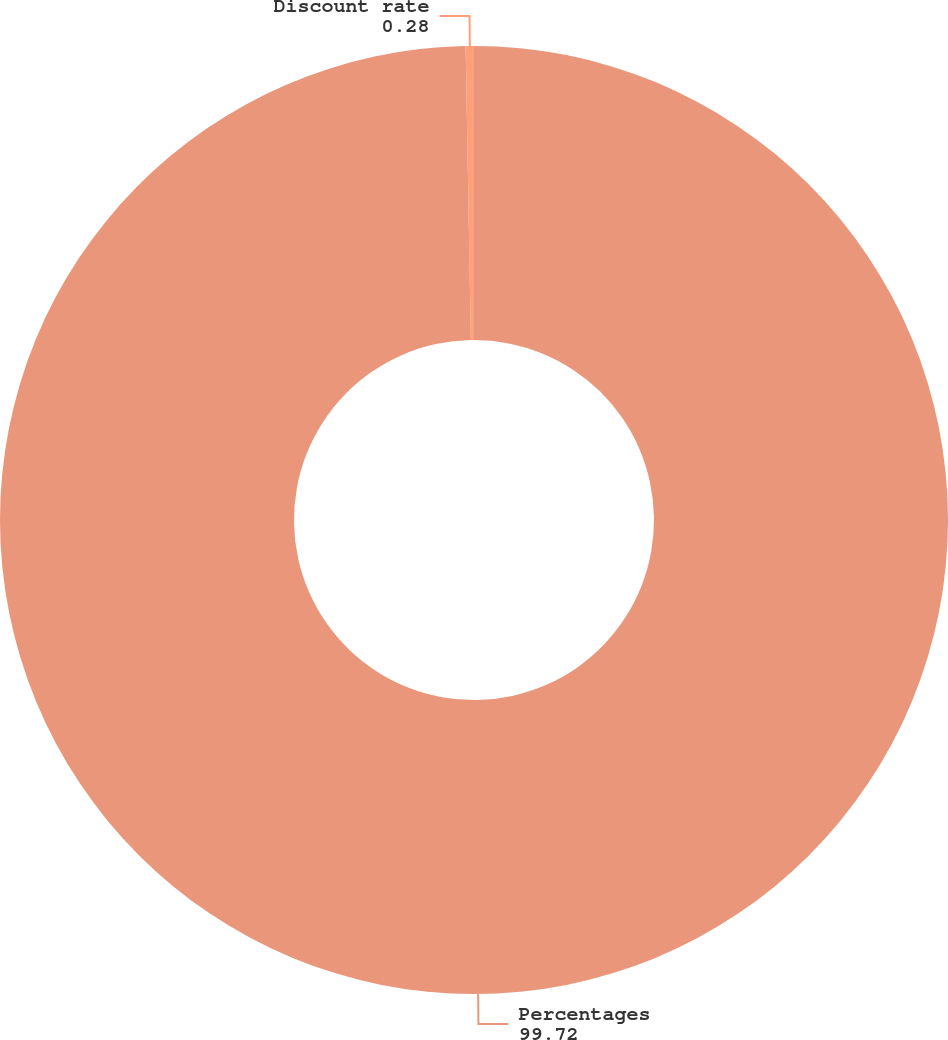Convert chart to OTSL. <chart><loc_0><loc_0><loc_500><loc_500><pie_chart><fcel>Percentages<fcel>Discount rate<nl><fcel>99.72%<fcel>0.28%<nl></chart> 